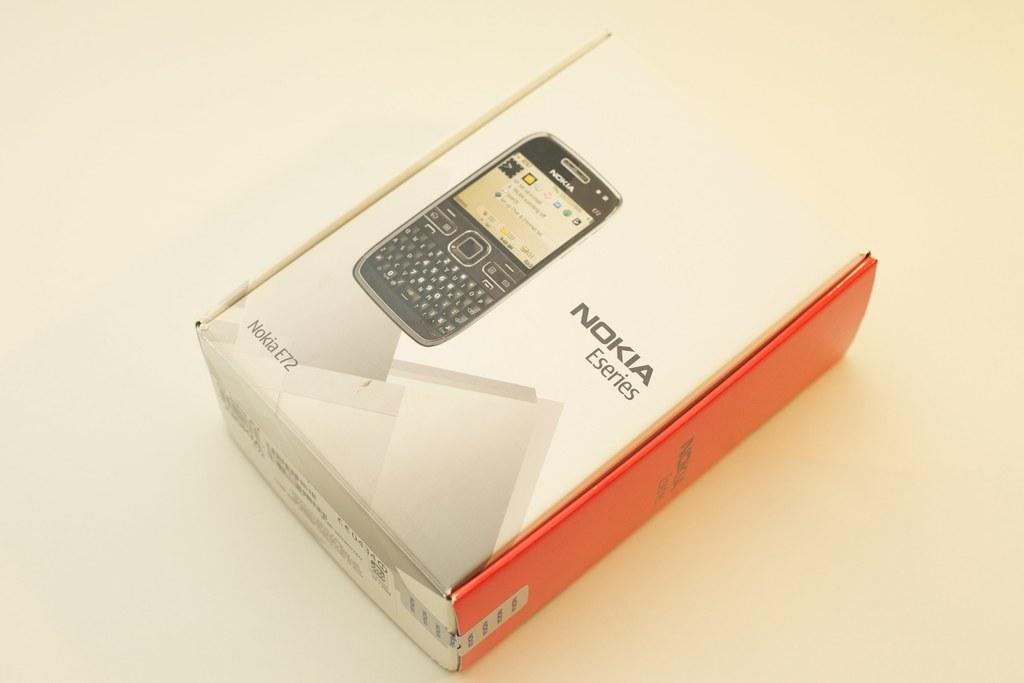<image>
Provide a brief description of the given image. a closed box for the nokia eseries cell phone 